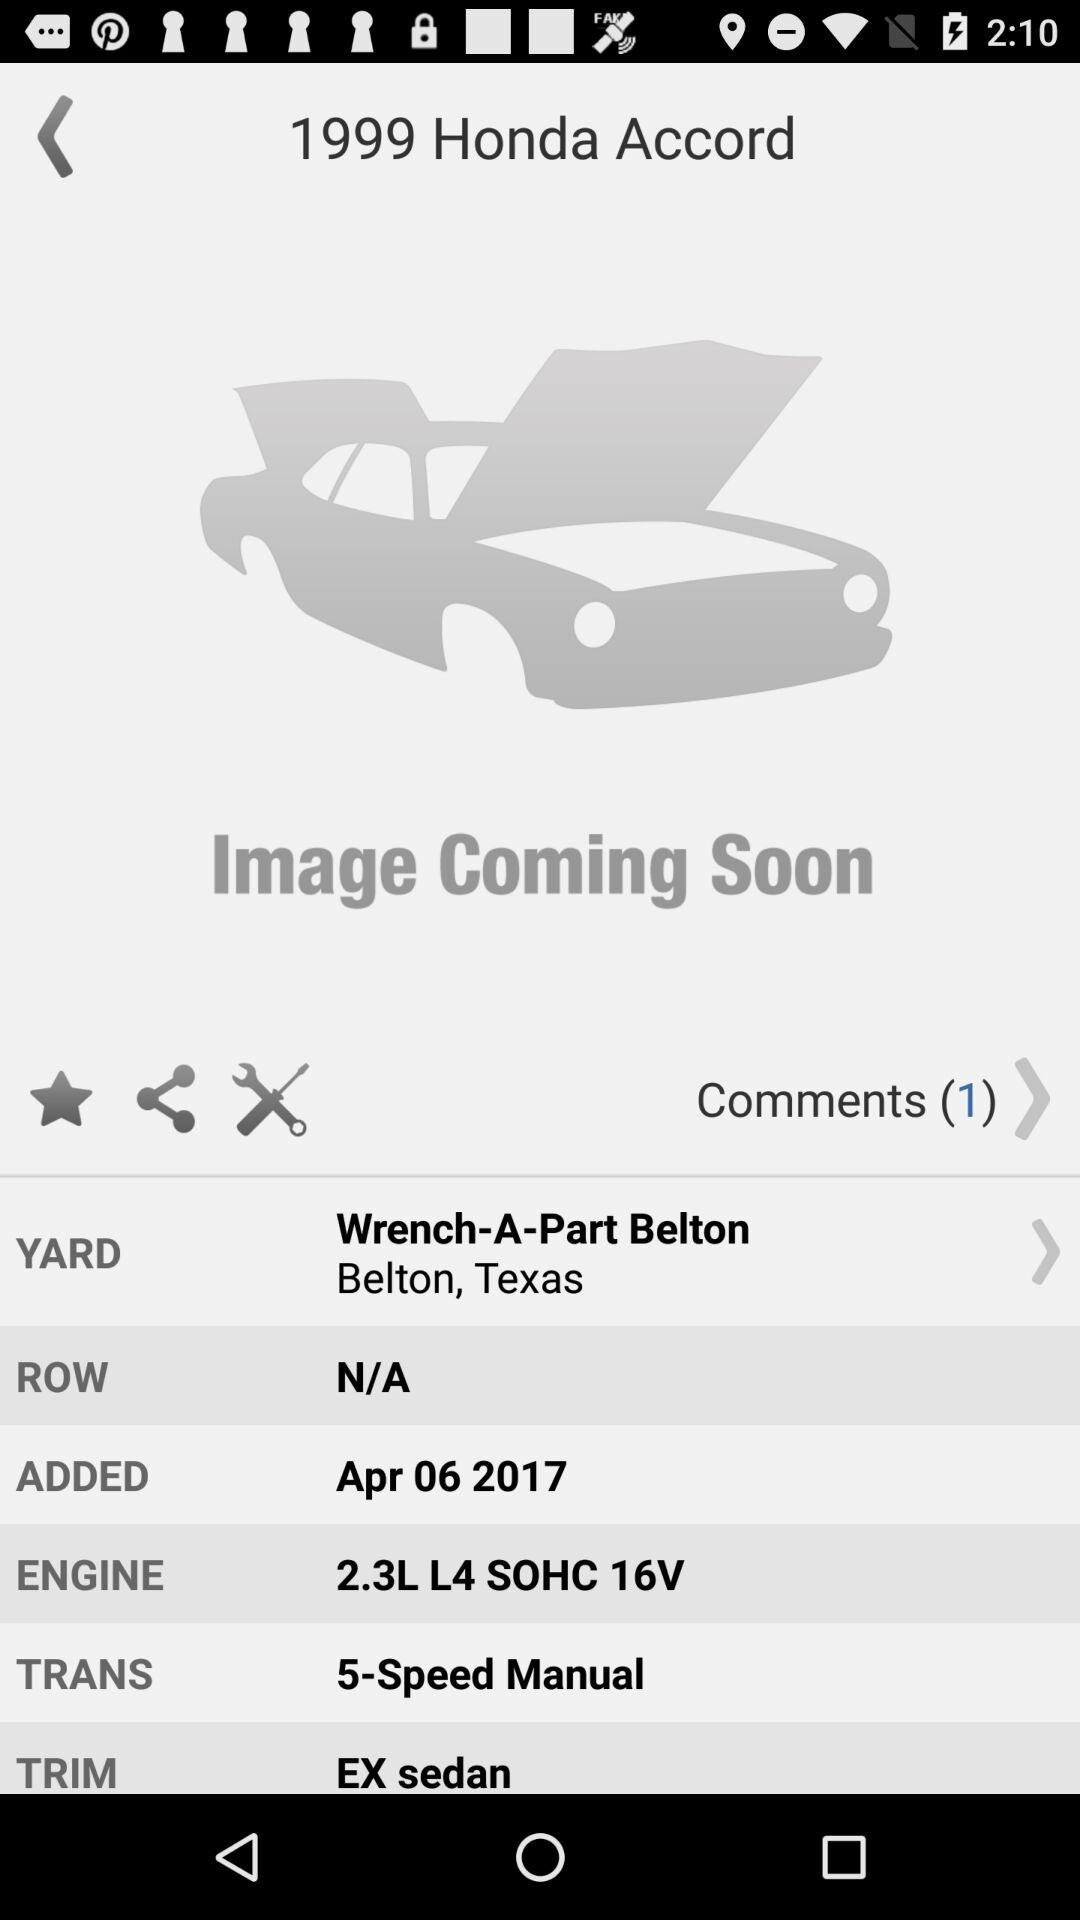What is the year of the vehicle?
Answer the question using a single word or phrase. 1999 